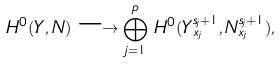Convert formula to latex. <formula><loc_0><loc_0><loc_500><loc_500>H ^ { 0 } ( Y , N ) \longrightarrow \bigoplus _ { j = 1 } ^ { p } \, H ^ { 0 } ( Y _ { x _ { j } } ^ { s _ { j } + 1 } , N _ { x _ { j } } ^ { s _ { j } + 1 } ) ,</formula> 